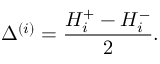<formula> <loc_0><loc_0><loc_500><loc_500>\Delta ^ { ( i ) } = \frac { H _ { i } ^ { + } - H _ { i } ^ { - } } { 2 } .</formula> 